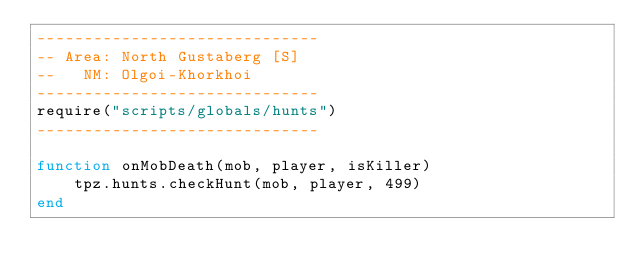Convert code to text. <code><loc_0><loc_0><loc_500><loc_500><_Lua_>------------------------------
-- Area: North Gustaberg [S]
--   NM: Olgoi-Khorkhoi
------------------------------
require("scripts/globals/hunts")
------------------------------

function onMobDeath(mob, player, isKiller)
    tpz.hunts.checkHunt(mob, player, 499)
end
</code> 